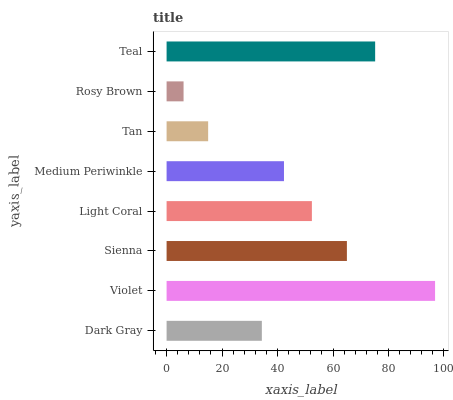Is Rosy Brown the minimum?
Answer yes or no. Yes. Is Violet the maximum?
Answer yes or no. Yes. Is Sienna the minimum?
Answer yes or no. No. Is Sienna the maximum?
Answer yes or no. No. Is Violet greater than Sienna?
Answer yes or no. Yes. Is Sienna less than Violet?
Answer yes or no. Yes. Is Sienna greater than Violet?
Answer yes or no. No. Is Violet less than Sienna?
Answer yes or no. No. Is Light Coral the high median?
Answer yes or no. Yes. Is Medium Periwinkle the low median?
Answer yes or no. Yes. Is Dark Gray the high median?
Answer yes or no. No. Is Tan the low median?
Answer yes or no. No. 